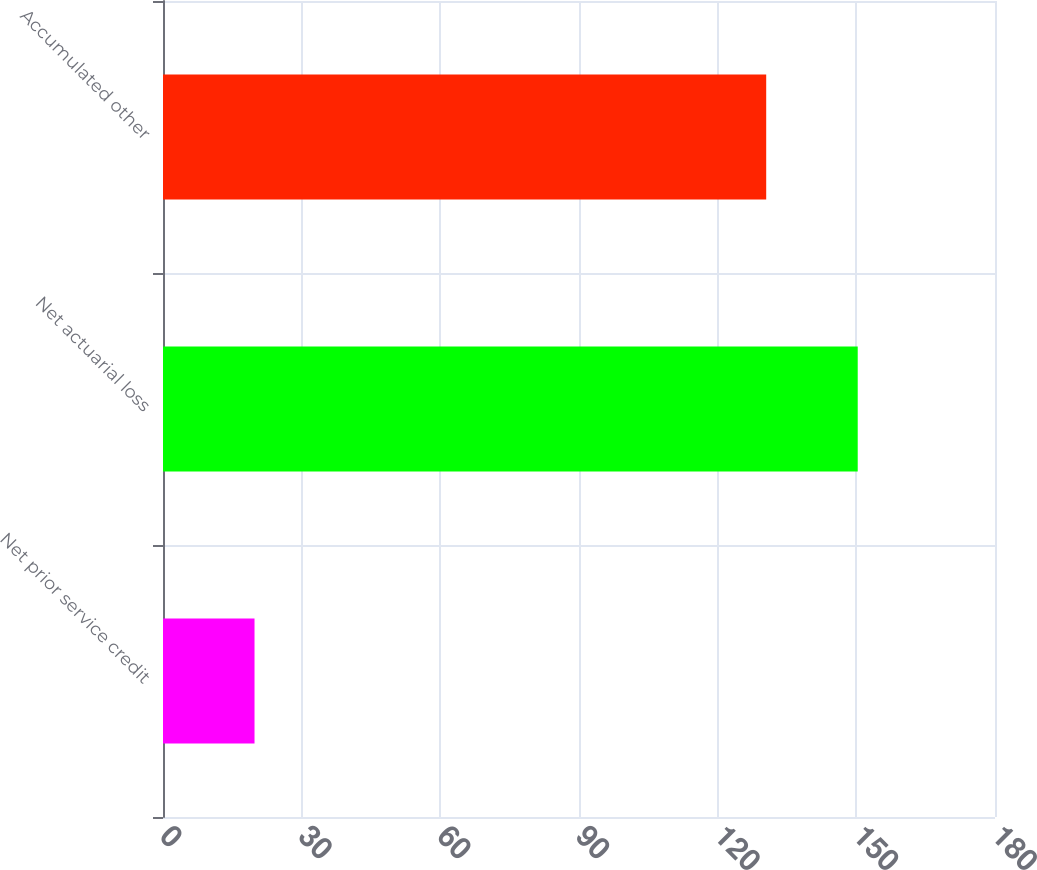Convert chart. <chart><loc_0><loc_0><loc_500><loc_500><bar_chart><fcel>Net prior service credit<fcel>Net actuarial loss<fcel>Accumulated other<nl><fcel>19.8<fcel>150.3<fcel>130.5<nl></chart> 